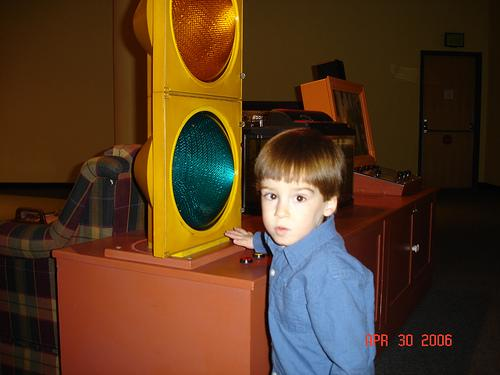What is the color and type of the shirt the boy is wearing? The boy is wearing a blue button-down shirt. How does the door for entering or leaving the room look like? The door has a silver bar. Describe the appearance of the couch in the background. The couch in the background is plaid. What color are the boy's eyes, and what is his hair color? The boy has brown eyes and brown hair. On which part of the stoplight is the green light located? The green light is on the bottom of the stoplight. Describe the boy's emotional expression in the image. The boy appears to have a neutral expression. Identify the unusual item in the room and describe where it is placed. A stoplight is in the room and it's placed on a table. Count the number of traffic light signals in the room. There is one traffic light in the room. What is the color of the walls in the room? The walls are beige. 